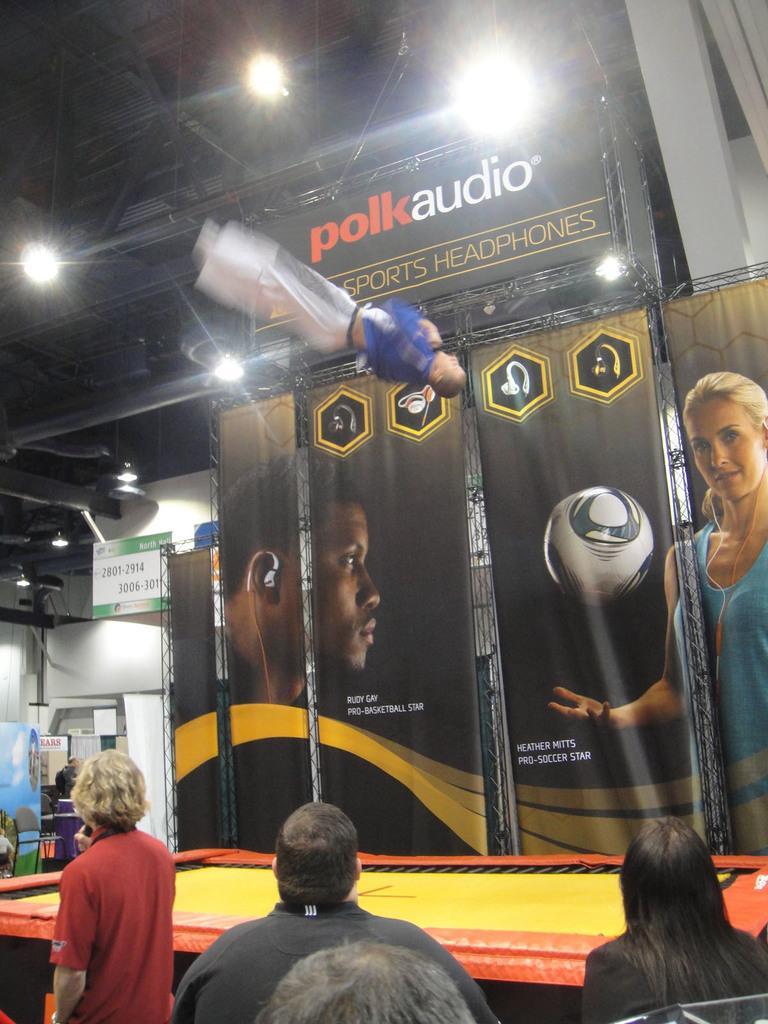Can you describe this image briefly? In this picture I can see few banners with some text and pictures and I can see a board with some text and I can see a trampoline and a human in the air and I can see few people and few lights on the ceiling and I can see a board with some text on it on the left side. 